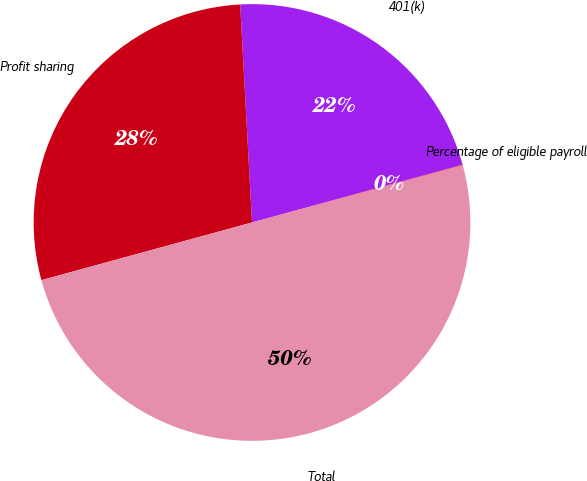Convert chart. <chart><loc_0><loc_0><loc_500><loc_500><pie_chart><fcel>401(k)<fcel>Profit sharing<fcel>Total<fcel>Percentage of eligible payroll<nl><fcel>21.59%<fcel>28.39%<fcel>49.98%<fcel>0.04%<nl></chart> 